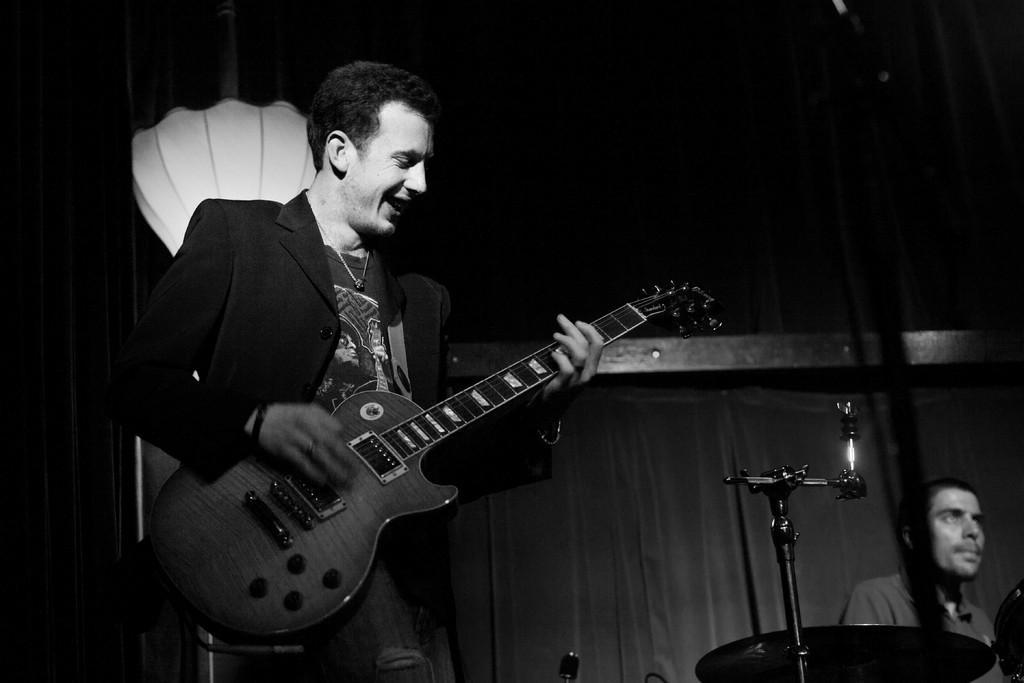Can you describe this image briefly? A man wearing a coat is holding a guitar and playing it. In the background there is a curtain. A stand is over there. A person is there in the background. 